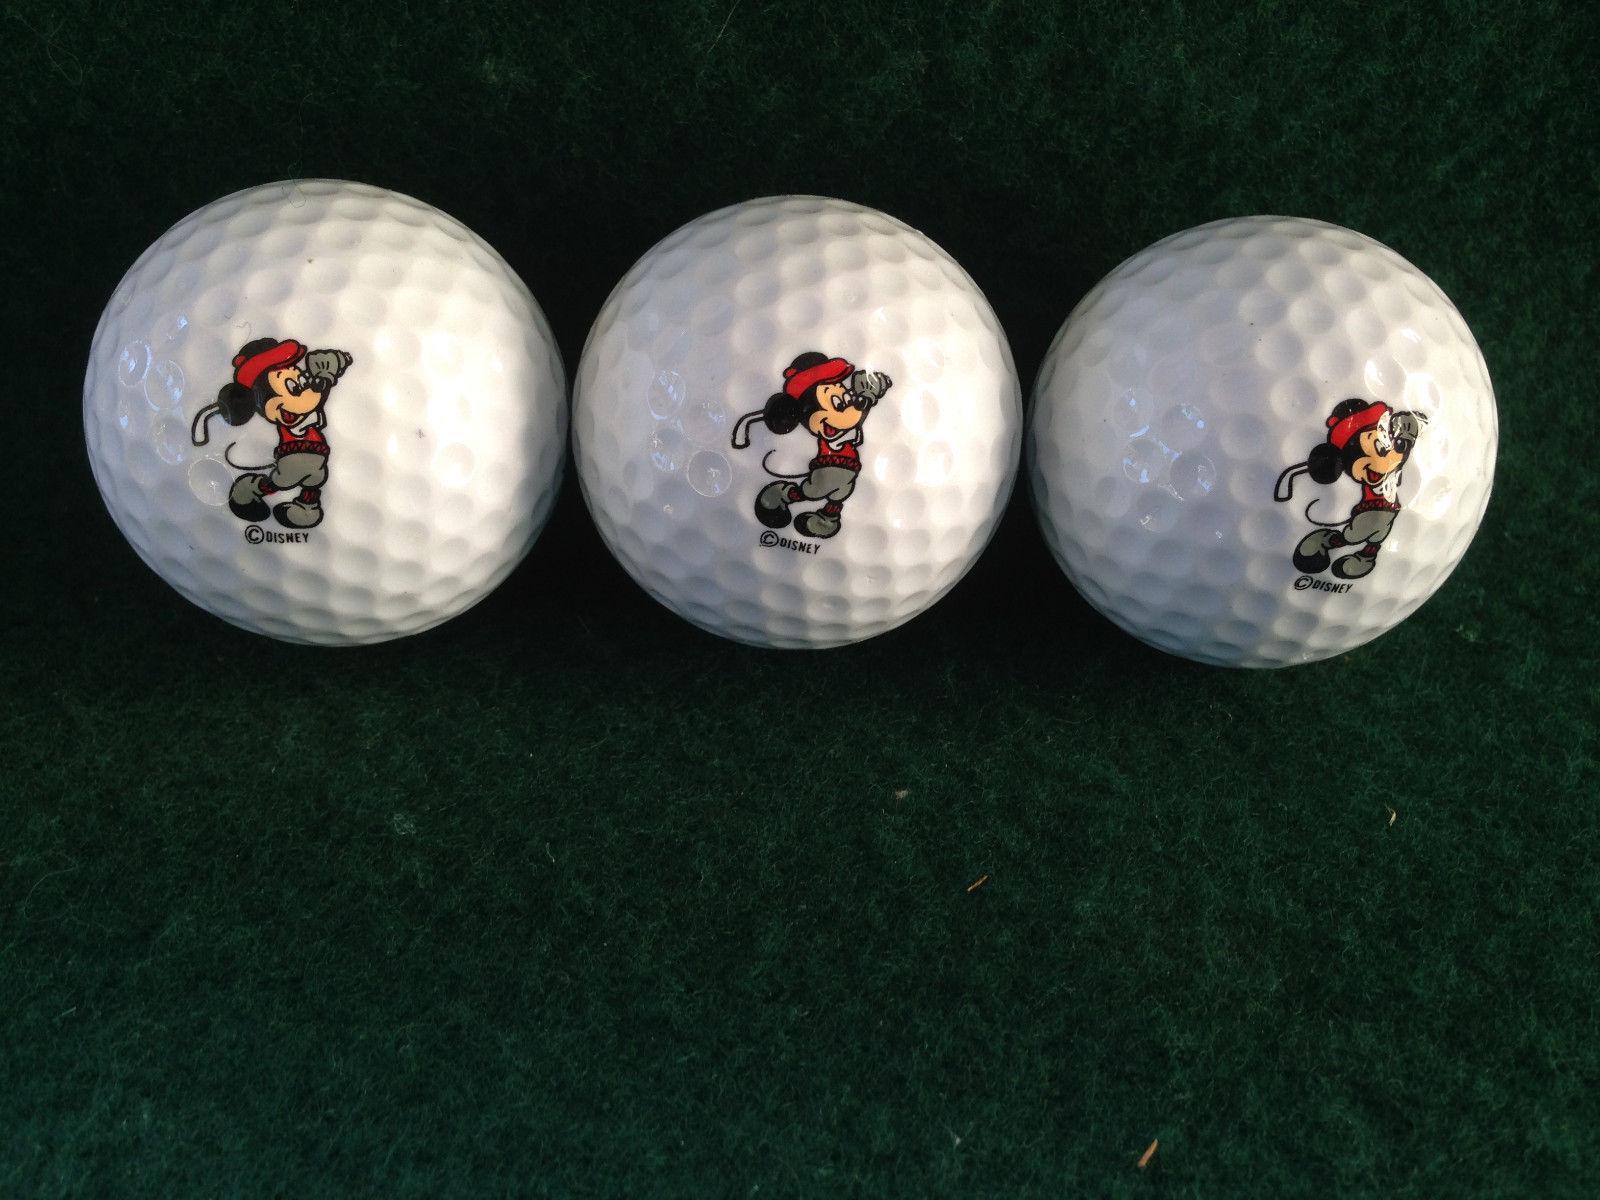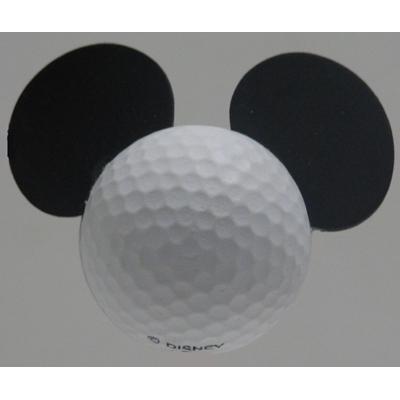The first image is the image on the left, the second image is the image on the right. For the images shown, is this caption "One image in the pair contains golf balls inside packaging." true? Answer yes or no. No. The first image is the image on the left, the second image is the image on the right. Examine the images to the left and right. Is the description "There is one golf ball with ears." accurate? Answer yes or no. Yes. 